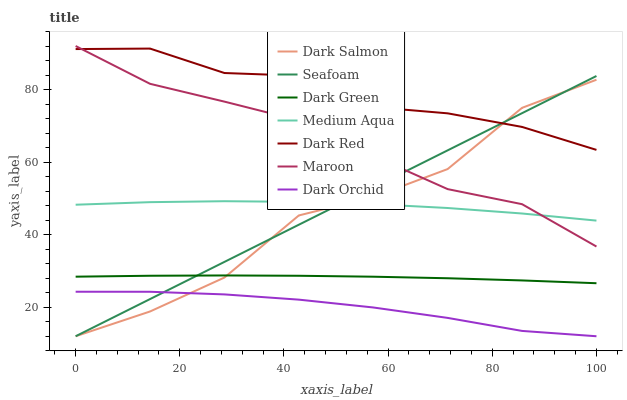Does Dark Salmon have the minimum area under the curve?
Answer yes or no. No. Does Dark Salmon have the maximum area under the curve?
Answer yes or no. No. Is Maroon the smoothest?
Answer yes or no. No. Is Maroon the roughest?
Answer yes or no. No. Does Maroon have the lowest value?
Answer yes or no. No. Does Dark Salmon have the highest value?
Answer yes or no. No. Is Dark Green less than Dark Red?
Answer yes or no. Yes. Is Dark Red greater than Dark Orchid?
Answer yes or no. Yes. Does Dark Green intersect Dark Red?
Answer yes or no. No. 